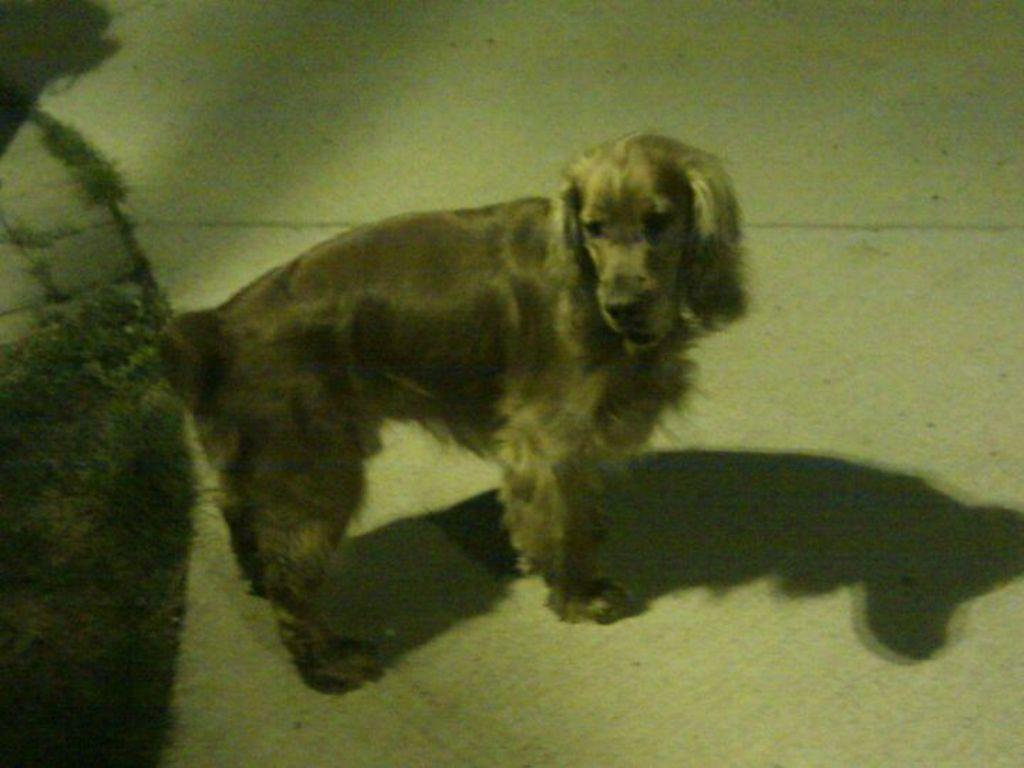What type of animal is in the image? There is a dog in the image. What color is the dog? The dog is brown in color. What is the color of the background in the image? The background of the image is cream in color. What reason does the dog have for wearing a summer hat in the image? There is no hat present on the dog in the image, and therefore no reason for it to be wearing one. What type of bottle can be seen in the image? There is no bottle present in the image. 